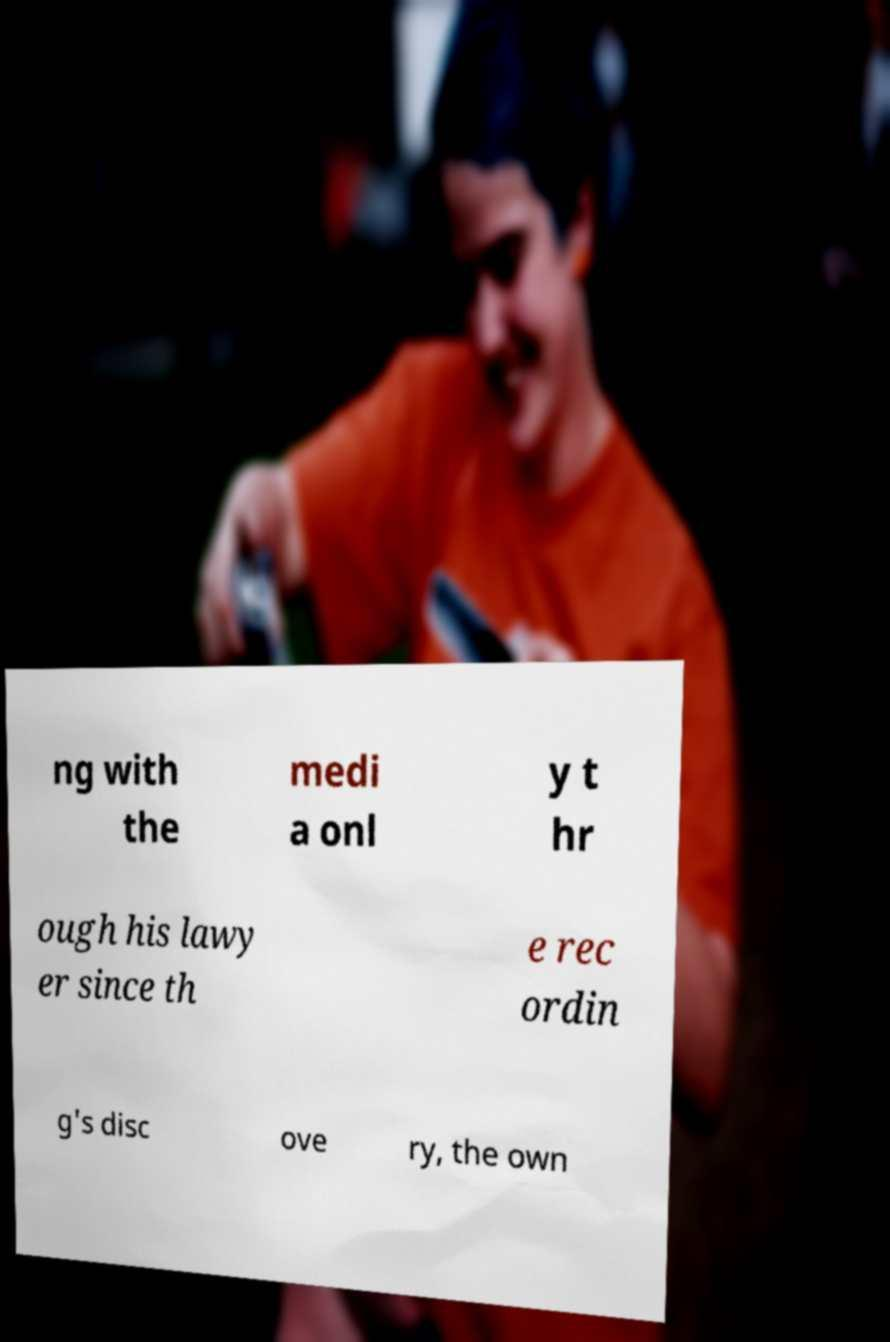I need the written content from this picture converted into text. Can you do that? ng with the medi a onl y t hr ough his lawy er since th e rec ordin g's disc ove ry, the own 